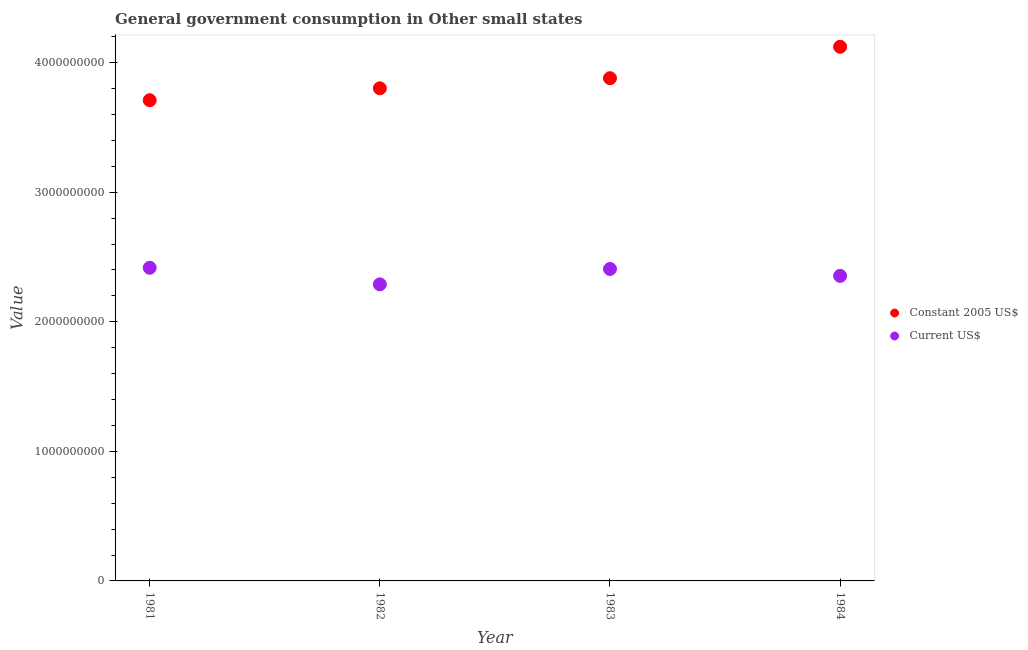Is the number of dotlines equal to the number of legend labels?
Provide a succinct answer. Yes. What is the value consumed in constant 2005 us$ in 1982?
Keep it short and to the point. 3.80e+09. Across all years, what is the maximum value consumed in current us$?
Provide a short and direct response. 2.42e+09. Across all years, what is the minimum value consumed in constant 2005 us$?
Give a very brief answer. 3.71e+09. In which year was the value consumed in constant 2005 us$ minimum?
Offer a terse response. 1981. What is the total value consumed in constant 2005 us$ in the graph?
Keep it short and to the point. 1.55e+1. What is the difference between the value consumed in constant 2005 us$ in 1983 and that in 1984?
Make the answer very short. -2.43e+08. What is the difference between the value consumed in constant 2005 us$ in 1982 and the value consumed in current us$ in 1983?
Make the answer very short. 1.39e+09. What is the average value consumed in current us$ per year?
Provide a short and direct response. 2.37e+09. In the year 1983, what is the difference between the value consumed in constant 2005 us$ and value consumed in current us$?
Offer a very short reply. 1.47e+09. In how many years, is the value consumed in constant 2005 us$ greater than 3800000000?
Your answer should be very brief. 3. What is the ratio of the value consumed in constant 2005 us$ in 1982 to that in 1984?
Your answer should be very brief. 0.92. Is the value consumed in constant 2005 us$ in 1981 less than that in 1984?
Give a very brief answer. Yes. Is the difference between the value consumed in current us$ in 1982 and 1983 greater than the difference between the value consumed in constant 2005 us$ in 1982 and 1983?
Offer a very short reply. No. What is the difference between the highest and the second highest value consumed in constant 2005 us$?
Provide a succinct answer. 2.43e+08. What is the difference between the highest and the lowest value consumed in current us$?
Your answer should be compact. 1.28e+08. Is the sum of the value consumed in current us$ in 1981 and 1984 greater than the maximum value consumed in constant 2005 us$ across all years?
Provide a short and direct response. Yes. Does the value consumed in constant 2005 us$ monotonically increase over the years?
Provide a succinct answer. Yes. Is the value consumed in constant 2005 us$ strictly greater than the value consumed in current us$ over the years?
Make the answer very short. Yes. How many dotlines are there?
Ensure brevity in your answer.  2. Does the graph contain grids?
Make the answer very short. No. What is the title of the graph?
Offer a very short reply. General government consumption in Other small states. What is the label or title of the Y-axis?
Keep it short and to the point. Value. What is the Value of Constant 2005 US$ in 1981?
Your answer should be compact. 3.71e+09. What is the Value of Current US$ in 1981?
Ensure brevity in your answer.  2.42e+09. What is the Value in Constant 2005 US$ in 1982?
Provide a short and direct response. 3.80e+09. What is the Value in Current US$ in 1982?
Offer a very short reply. 2.29e+09. What is the Value in Constant 2005 US$ in 1983?
Keep it short and to the point. 3.88e+09. What is the Value of Current US$ in 1983?
Provide a short and direct response. 2.41e+09. What is the Value of Constant 2005 US$ in 1984?
Offer a very short reply. 4.12e+09. What is the Value in Current US$ in 1984?
Keep it short and to the point. 2.35e+09. Across all years, what is the maximum Value in Constant 2005 US$?
Offer a terse response. 4.12e+09. Across all years, what is the maximum Value of Current US$?
Your answer should be very brief. 2.42e+09. Across all years, what is the minimum Value in Constant 2005 US$?
Your answer should be compact. 3.71e+09. Across all years, what is the minimum Value of Current US$?
Your answer should be very brief. 2.29e+09. What is the total Value in Constant 2005 US$ in the graph?
Offer a terse response. 1.55e+1. What is the total Value of Current US$ in the graph?
Make the answer very short. 9.47e+09. What is the difference between the Value of Constant 2005 US$ in 1981 and that in 1982?
Offer a very short reply. -9.20e+07. What is the difference between the Value in Current US$ in 1981 and that in 1982?
Your answer should be compact. 1.28e+08. What is the difference between the Value in Constant 2005 US$ in 1981 and that in 1983?
Provide a short and direct response. -1.70e+08. What is the difference between the Value in Current US$ in 1981 and that in 1983?
Offer a very short reply. 9.20e+06. What is the difference between the Value of Constant 2005 US$ in 1981 and that in 1984?
Make the answer very short. -4.13e+08. What is the difference between the Value in Current US$ in 1981 and that in 1984?
Offer a very short reply. 6.26e+07. What is the difference between the Value in Constant 2005 US$ in 1982 and that in 1983?
Give a very brief answer. -7.80e+07. What is the difference between the Value of Current US$ in 1982 and that in 1983?
Keep it short and to the point. -1.19e+08. What is the difference between the Value in Constant 2005 US$ in 1982 and that in 1984?
Give a very brief answer. -3.21e+08. What is the difference between the Value in Current US$ in 1982 and that in 1984?
Offer a terse response. -6.55e+07. What is the difference between the Value of Constant 2005 US$ in 1983 and that in 1984?
Make the answer very short. -2.43e+08. What is the difference between the Value in Current US$ in 1983 and that in 1984?
Your response must be concise. 5.34e+07. What is the difference between the Value of Constant 2005 US$ in 1981 and the Value of Current US$ in 1982?
Provide a succinct answer. 1.42e+09. What is the difference between the Value of Constant 2005 US$ in 1981 and the Value of Current US$ in 1983?
Provide a succinct answer. 1.30e+09. What is the difference between the Value in Constant 2005 US$ in 1981 and the Value in Current US$ in 1984?
Keep it short and to the point. 1.36e+09. What is the difference between the Value of Constant 2005 US$ in 1982 and the Value of Current US$ in 1983?
Keep it short and to the point. 1.39e+09. What is the difference between the Value of Constant 2005 US$ in 1982 and the Value of Current US$ in 1984?
Offer a very short reply. 1.45e+09. What is the difference between the Value in Constant 2005 US$ in 1983 and the Value in Current US$ in 1984?
Give a very brief answer. 1.53e+09. What is the average Value in Constant 2005 US$ per year?
Offer a very short reply. 3.88e+09. What is the average Value in Current US$ per year?
Make the answer very short. 2.37e+09. In the year 1981, what is the difference between the Value of Constant 2005 US$ and Value of Current US$?
Offer a very short reply. 1.29e+09. In the year 1982, what is the difference between the Value in Constant 2005 US$ and Value in Current US$?
Provide a succinct answer. 1.51e+09. In the year 1983, what is the difference between the Value of Constant 2005 US$ and Value of Current US$?
Provide a short and direct response. 1.47e+09. In the year 1984, what is the difference between the Value in Constant 2005 US$ and Value in Current US$?
Provide a short and direct response. 1.77e+09. What is the ratio of the Value in Constant 2005 US$ in 1981 to that in 1982?
Keep it short and to the point. 0.98. What is the ratio of the Value in Current US$ in 1981 to that in 1982?
Your answer should be very brief. 1.06. What is the ratio of the Value of Constant 2005 US$ in 1981 to that in 1983?
Make the answer very short. 0.96. What is the ratio of the Value of Current US$ in 1981 to that in 1983?
Your answer should be very brief. 1. What is the ratio of the Value of Constant 2005 US$ in 1981 to that in 1984?
Offer a terse response. 0.9. What is the ratio of the Value in Current US$ in 1981 to that in 1984?
Provide a succinct answer. 1.03. What is the ratio of the Value in Constant 2005 US$ in 1982 to that in 1983?
Provide a succinct answer. 0.98. What is the ratio of the Value in Current US$ in 1982 to that in 1983?
Give a very brief answer. 0.95. What is the ratio of the Value in Constant 2005 US$ in 1982 to that in 1984?
Give a very brief answer. 0.92. What is the ratio of the Value in Current US$ in 1982 to that in 1984?
Make the answer very short. 0.97. What is the ratio of the Value of Constant 2005 US$ in 1983 to that in 1984?
Offer a very short reply. 0.94. What is the ratio of the Value of Current US$ in 1983 to that in 1984?
Your answer should be very brief. 1.02. What is the difference between the highest and the second highest Value in Constant 2005 US$?
Your response must be concise. 2.43e+08. What is the difference between the highest and the second highest Value in Current US$?
Provide a short and direct response. 9.20e+06. What is the difference between the highest and the lowest Value in Constant 2005 US$?
Provide a short and direct response. 4.13e+08. What is the difference between the highest and the lowest Value of Current US$?
Offer a terse response. 1.28e+08. 